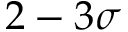<formula> <loc_0><loc_0><loc_500><loc_500>2 - 3 \sigma</formula> 